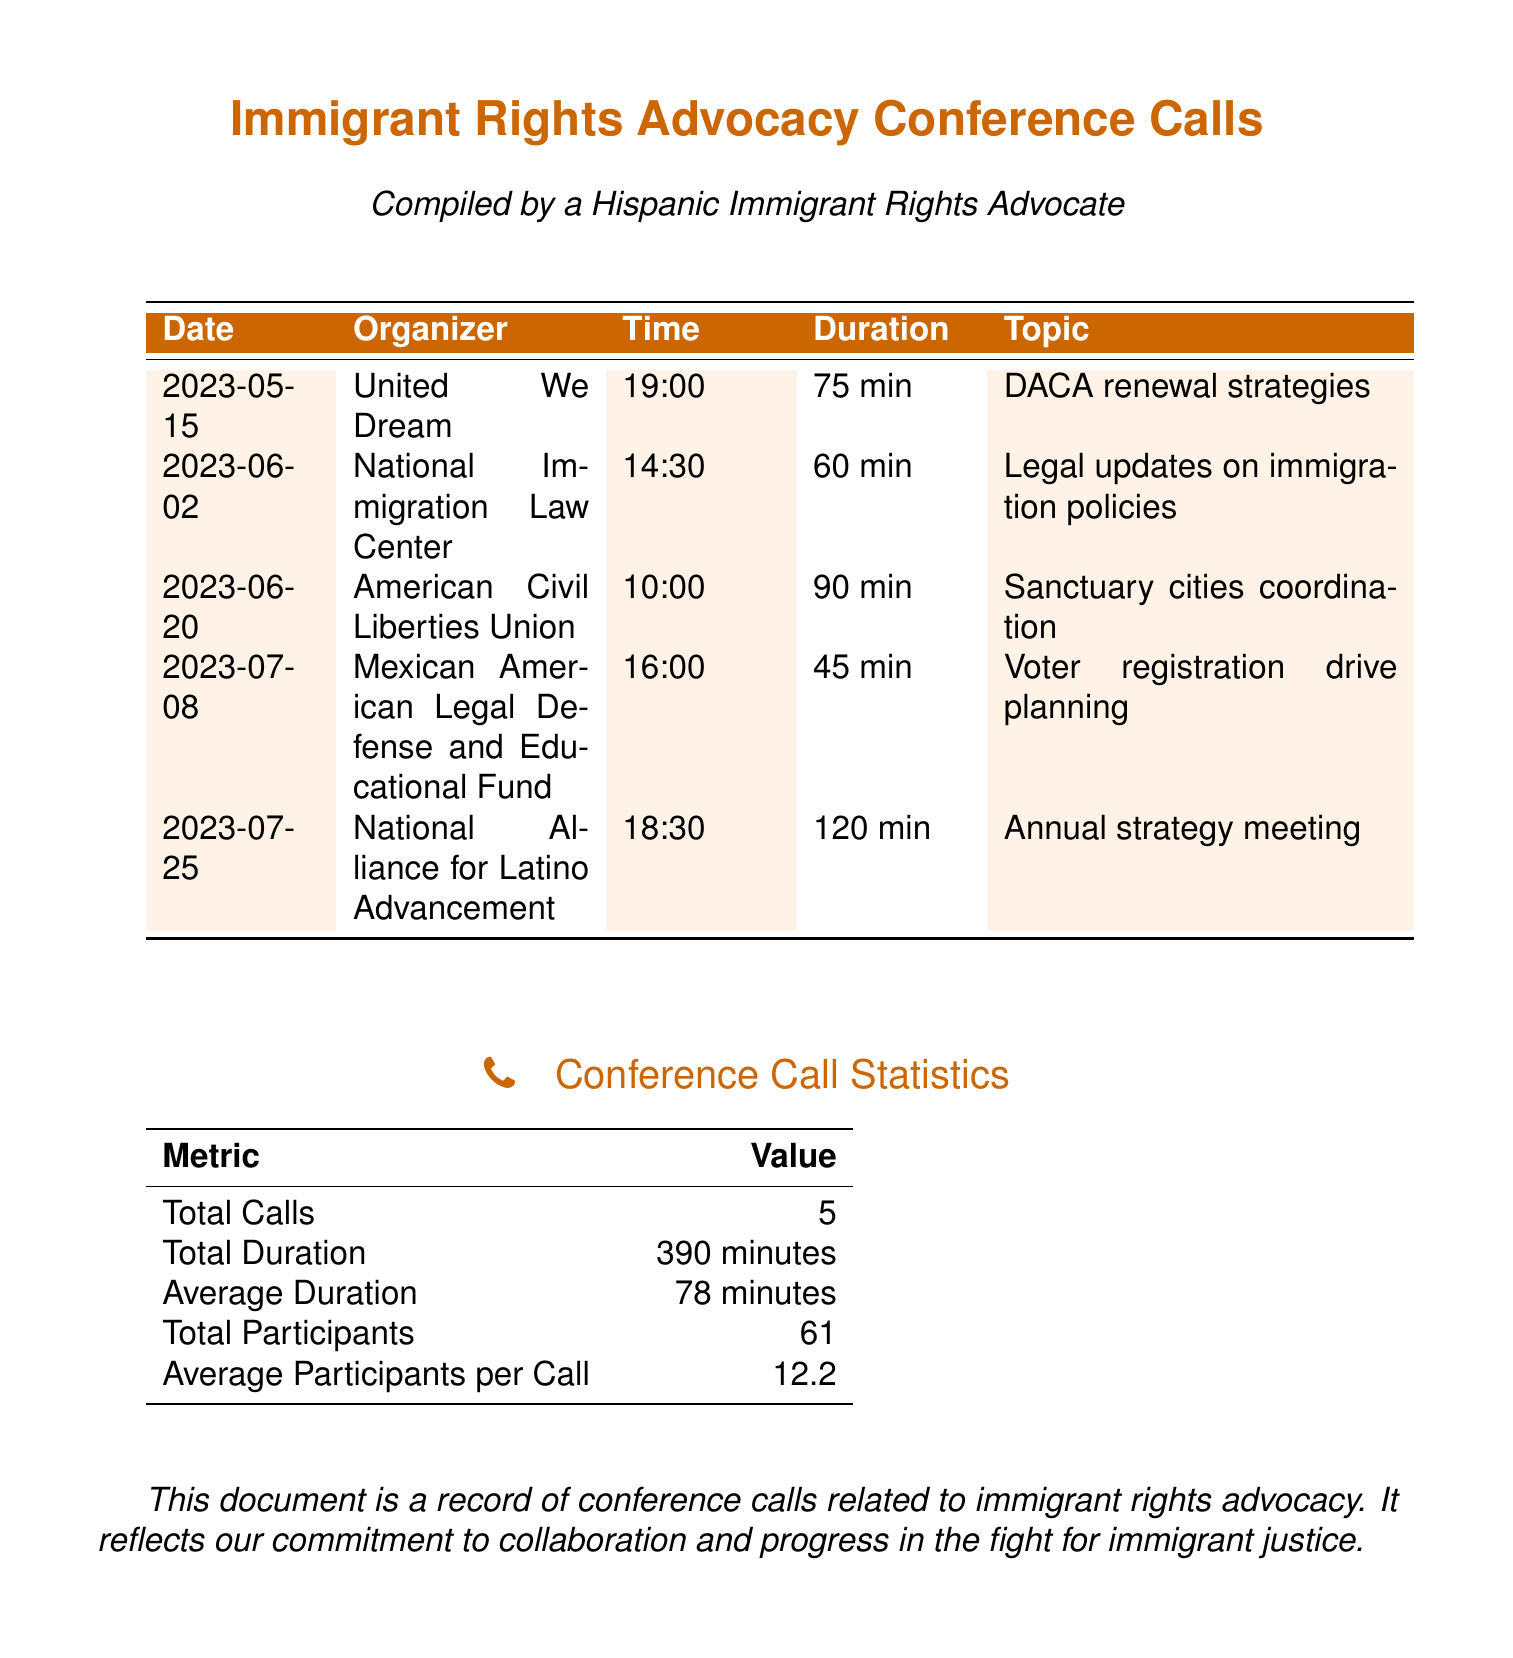What was the date of the call about DACA renewal strategies? The date of the call about DACA renewal strategies is found in the first row of the table.
Answer: 2023-05-15 Who organized the call on legal updates on immigration policies? The organizer for the call on legal updates is listed in the second row of the table.
Answer: National Immigration Law Center What is the duration of the call focused on sanctuary cities coordination? The duration of the sanctuary cities coordination call is provided in the third row of the table.
Answer: 90 min How many total participants were involved in the conference calls? The total number of participants is mentioned in the conference call statistics section.
Answer: 61 What is the average duration of the calls? The average duration can be calculated from the total duration and the number of calls listed.
Answer: 78 minutes Which call was the longest in duration? The longest call's duration is the one listed in the table that has the highest value in the duration column.
Answer: 120 min What topic was discussed in the call held on July 8? The topic for the call on July 8 is found in the corresponding row in the table.
Answer: Voter registration drive planning Which organization conducted the annual strategy meeting? The organization hosting the annual strategy meeting is detailed in the entry for July 25 in the table.
Answer: National Alliance for Latino Advancement 